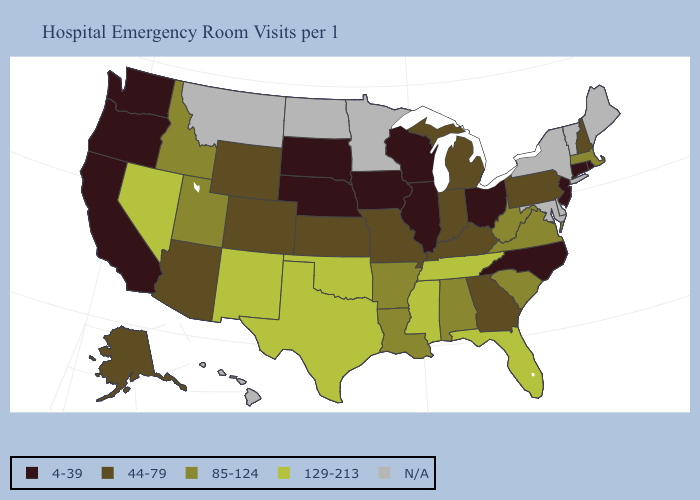What is the value of Ohio?
Write a very short answer. 4-39. Which states have the lowest value in the South?
Keep it brief. North Carolina. Does Texas have the highest value in the USA?
Short answer required. Yes. Name the states that have a value in the range N/A?
Write a very short answer. Delaware, Hawaii, Maine, Maryland, Minnesota, Montana, New York, North Dakota, Vermont. Name the states that have a value in the range 85-124?
Concise answer only. Alabama, Arkansas, Idaho, Louisiana, Massachusetts, South Carolina, Utah, Virginia, West Virginia. What is the highest value in states that border Tennessee?
Short answer required. 129-213. What is the value of Washington?
Be succinct. 4-39. What is the highest value in the USA?
Be succinct. 129-213. What is the value of Alabama?
Write a very short answer. 85-124. Name the states that have a value in the range 44-79?
Give a very brief answer. Alaska, Arizona, Colorado, Georgia, Indiana, Kansas, Kentucky, Michigan, Missouri, New Hampshire, Pennsylvania, Wyoming. What is the value of Virginia?
Concise answer only. 85-124. Among the states that border Delaware , which have the lowest value?
Short answer required. New Jersey. Does the map have missing data?
Be succinct. Yes. Name the states that have a value in the range N/A?
Give a very brief answer. Delaware, Hawaii, Maine, Maryland, Minnesota, Montana, New York, North Dakota, Vermont. 